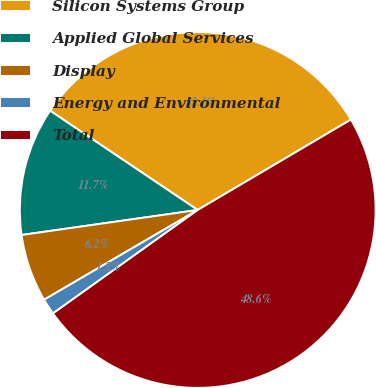Convert chart to OTSL. <chart><loc_0><loc_0><loc_500><loc_500><pie_chart><fcel>Silicon Systems Group<fcel>Applied Global Services<fcel>Display<fcel>Energy and Environmental<fcel>Total<nl><fcel>32.09%<fcel>11.67%<fcel>6.17%<fcel>1.46%<fcel>48.61%<nl></chart> 